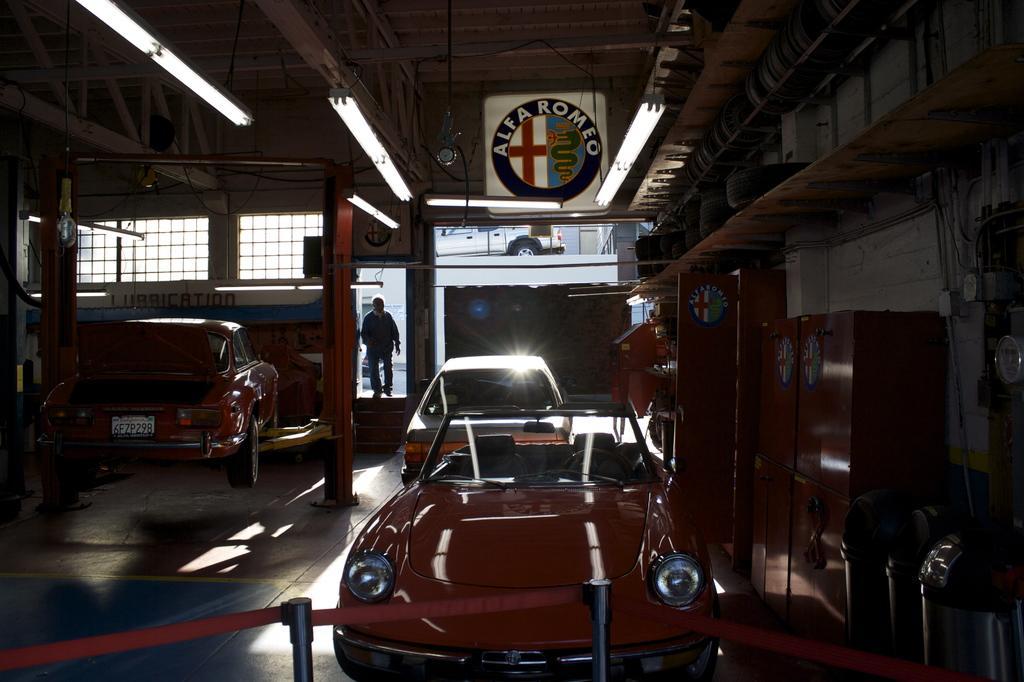Please provide a concise description of this image. In this image we can see a few vehicles in a room which looks like garage and there is a person walking and we can see the lights attached to the ceiling. We can see the rack with tires and some other things on the right side of the image and there is a board with some text. 